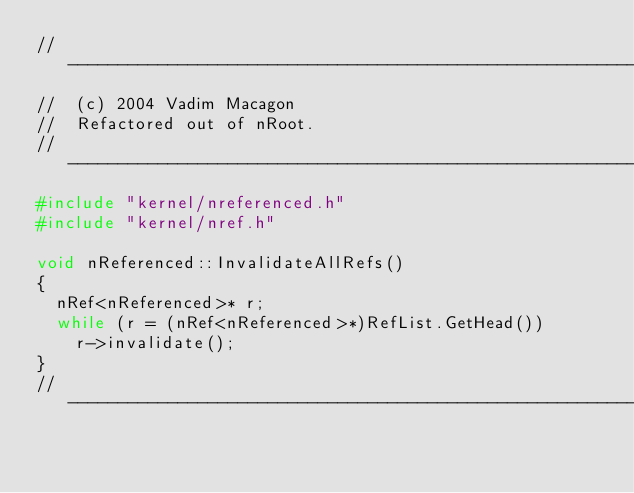<code> <loc_0><loc_0><loc_500><loc_500><_C++_>//------------------------------------------------------------------------------
//  (c) 2004 Vadim Macagon
//  Refactored out of nRoot.
//------------------------------------------------------------------------------
#include "kernel/nreferenced.h"
#include "kernel/nref.h"

void nReferenced::InvalidateAllRefs()
{
	nRef<nReferenced>* r;
	while (r = (nRef<nReferenced>*)RefList.GetHead())
		r->invalidate();
}
//---------------------------------------------------------------------
</code> 